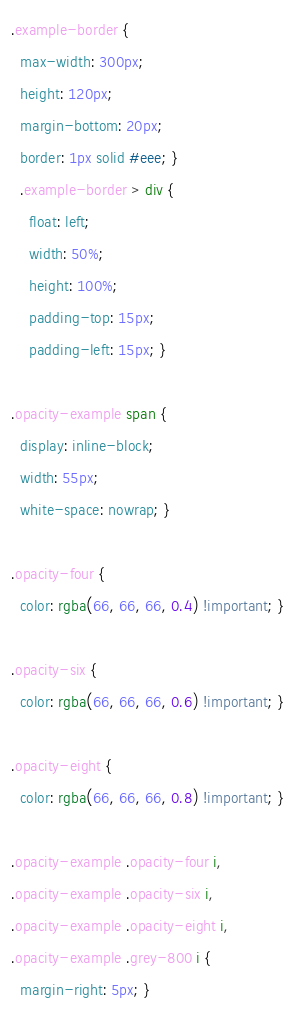Convert code to text. <code><loc_0><loc_0><loc_500><loc_500><_CSS_>.example-border {
  max-width: 300px;
  height: 120px;
  margin-bottom: 20px;
  border: 1px solid #eee; }
  .example-border > div {
    float: left;
    width: 50%;
    height: 100%;
    padding-top: 15px;
    padding-left: 15px; }

.opacity-example span {
  display: inline-block;
  width: 55px;
  white-space: nowrap; }

.opacity-four {
  color: rgba(66, 66, 66, 0.4) !important; }

.opacity-six {
  color: rgba(66, 66, 66, 0.6) !important; }

.opacity-eight {
  color: rgba(66, 66, 66, 0.8) !important; }

.opacity-example .opacity-four i,
.opacity-example .opacity-six i,
.opacity-example .opacity-eight i,
.opacity-example .grey-800 i {
  margin-right: 5px; }
</code> 